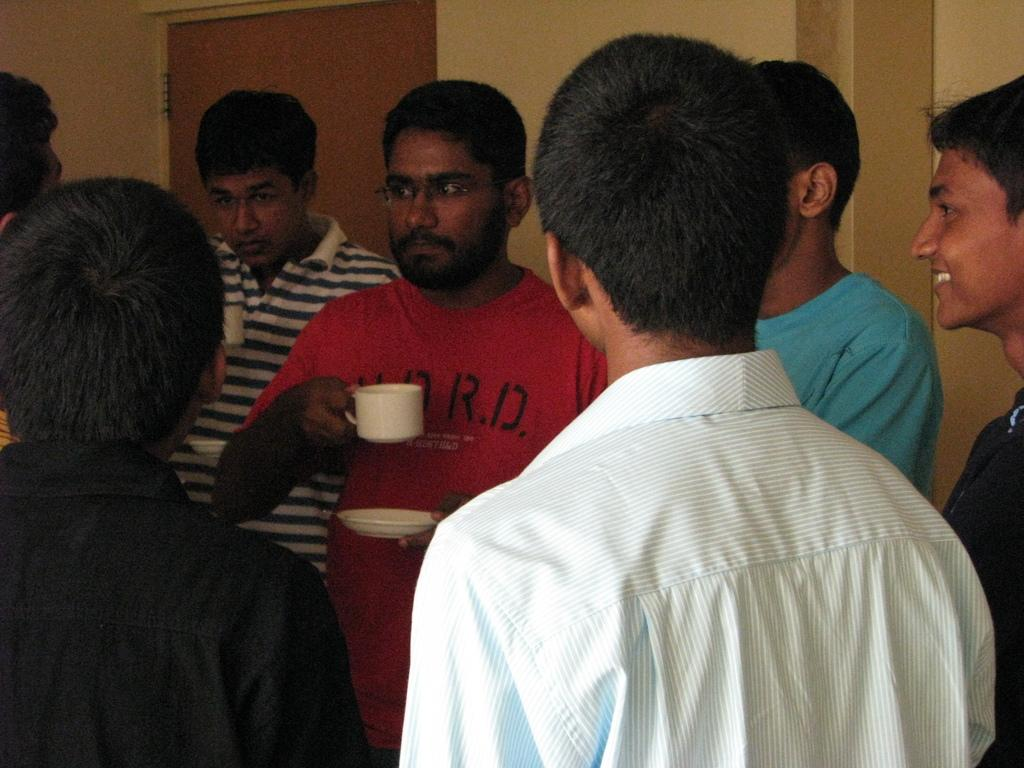What can be seen in the foreground of the image? There are persons standing in the foreground of the image. What are two of the persons holding? They are holding cups and saucers. What can be seen in the background of the image? There is a door and a wall in the background of the image. What type of carriage is visible in the image? There is no carriage present in the image. Can you describe the cannon that is being fired in the image? There is no cannon or any indication of firing in the image. 